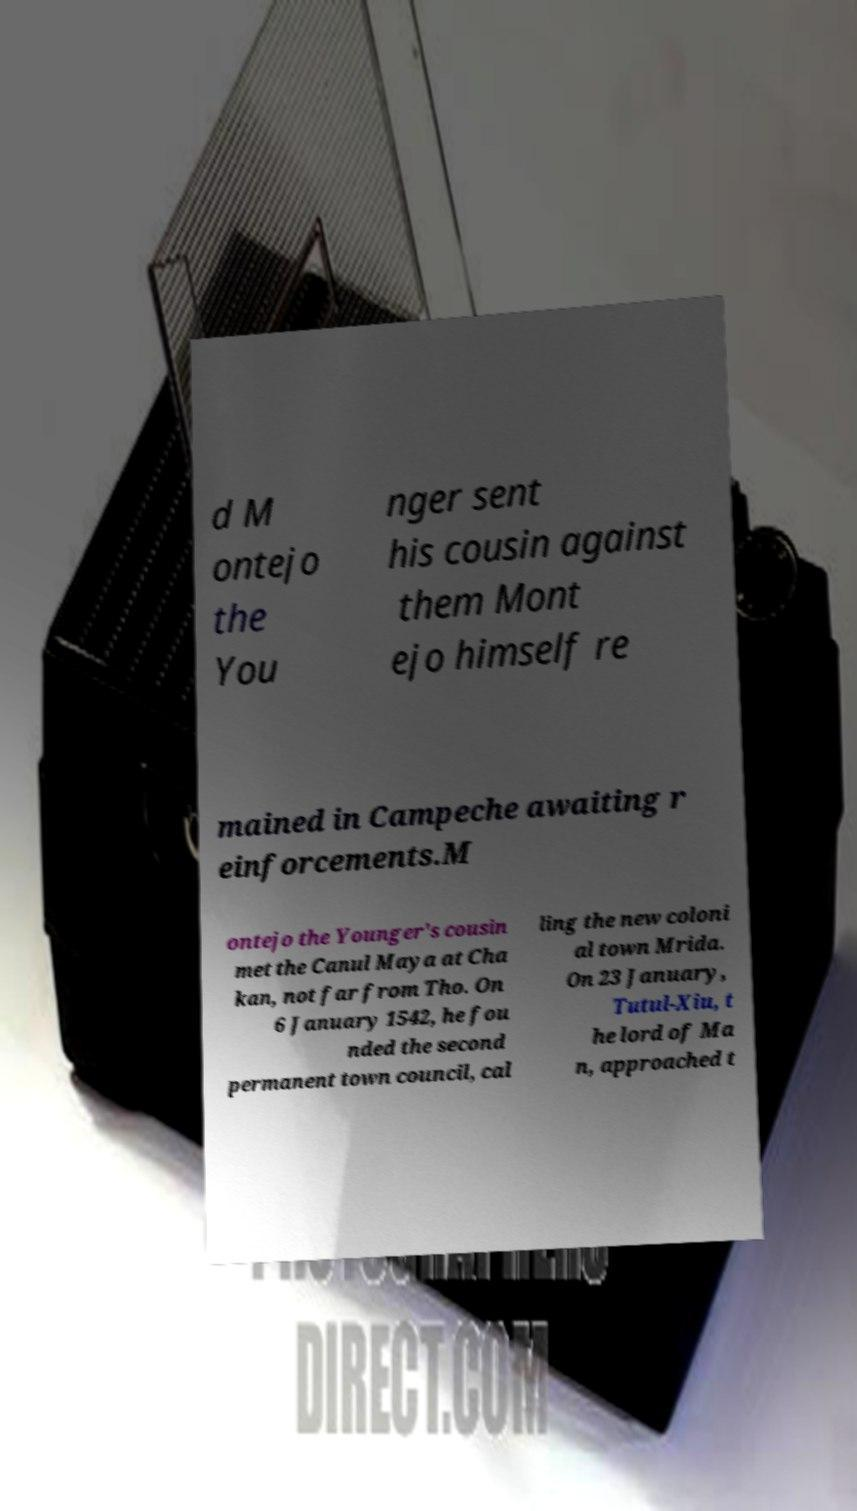Please read and relay the text visible in this image. What does it say? d M ontejo the You nger sent his cousin against them Mont ejo himself re mained in Campeche awaiting r einforcements.M ontejo the Younger's cousin met the Canul Maya at Cha kan, not far from Tho. On 6 January 1542, he fou nded the second permanent town council, cal ling the new coloni al town Mrida. On 23 January, Tutul-Xiu, t he lord of Ma n, approached t 